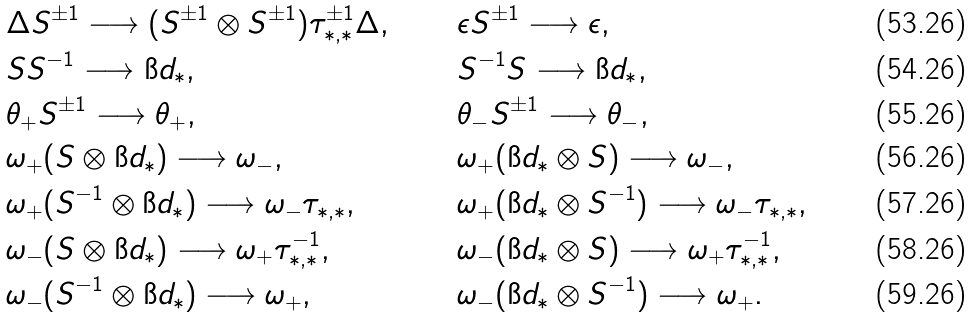<formula> <loc_0><loc_0><loc_500><loc_500>& \Delta S ^ { \pm 1 } \longrightarrow ( S ^ { \pm 1 } \otimes S ^ { \pm 1 } ) \tau ^ { \pm 1 } _ { * , * } \Delta , & & \epsilon S ^ { \pm 1 } \longrightarrow \epsilon , \\ & S S ^ { - 1 } \longrightarrow \i d _ { * } , & & S ^ { - 1 } S \longrightarrow \i d _ { * } , \\ & \theta _ { + } S ^ { \pm 1 } \longrightarrow \theta _ { + } , & & \theta _ { - } S ^ { \pm 1 } \longrightarrow \theta _ { - } , \\ & \omega _ { + } ( S \otimes \i d _ { * } ) \longrightarrow \omega _ { - } , & & \omega _ { + } ( \i d _ { * } \otimes S ) \longrightarrow \omega _ { - } , \\ & \omega _ { + } ( S ^ { - 1 } \otimes \i d _ { * } ) \longrightarrow \omega _ { - } \tau _ { * , * } , & & \omega _ { + } ( \i d _ { * } \otimes S ^ { - 1 } ) \longrightarrow \omega _ { - } \tau _ { * , * } , \\ & \omega _ { - } ( S \otimes \i d _ { * } ) \longrightarrow \omega _ { + } \tau ^ { - 1 } _ { * , * } , & & \omega _ { - } ( \i d _ { * } \otimes S ) \longrightarrow \omega _ { + } \tau ^ { - 1 } _ { * , * } , \\ & \omega _ { - } ( S ^ { - 1 } \otimes \i d _ { * } ) \longrightarrow \omega _ { + } , & & \omega _ { - } ( \i d _ { * } \otimes S ^ { - 1 } ) \longrightarrow \omega _ { + } .</formula> 